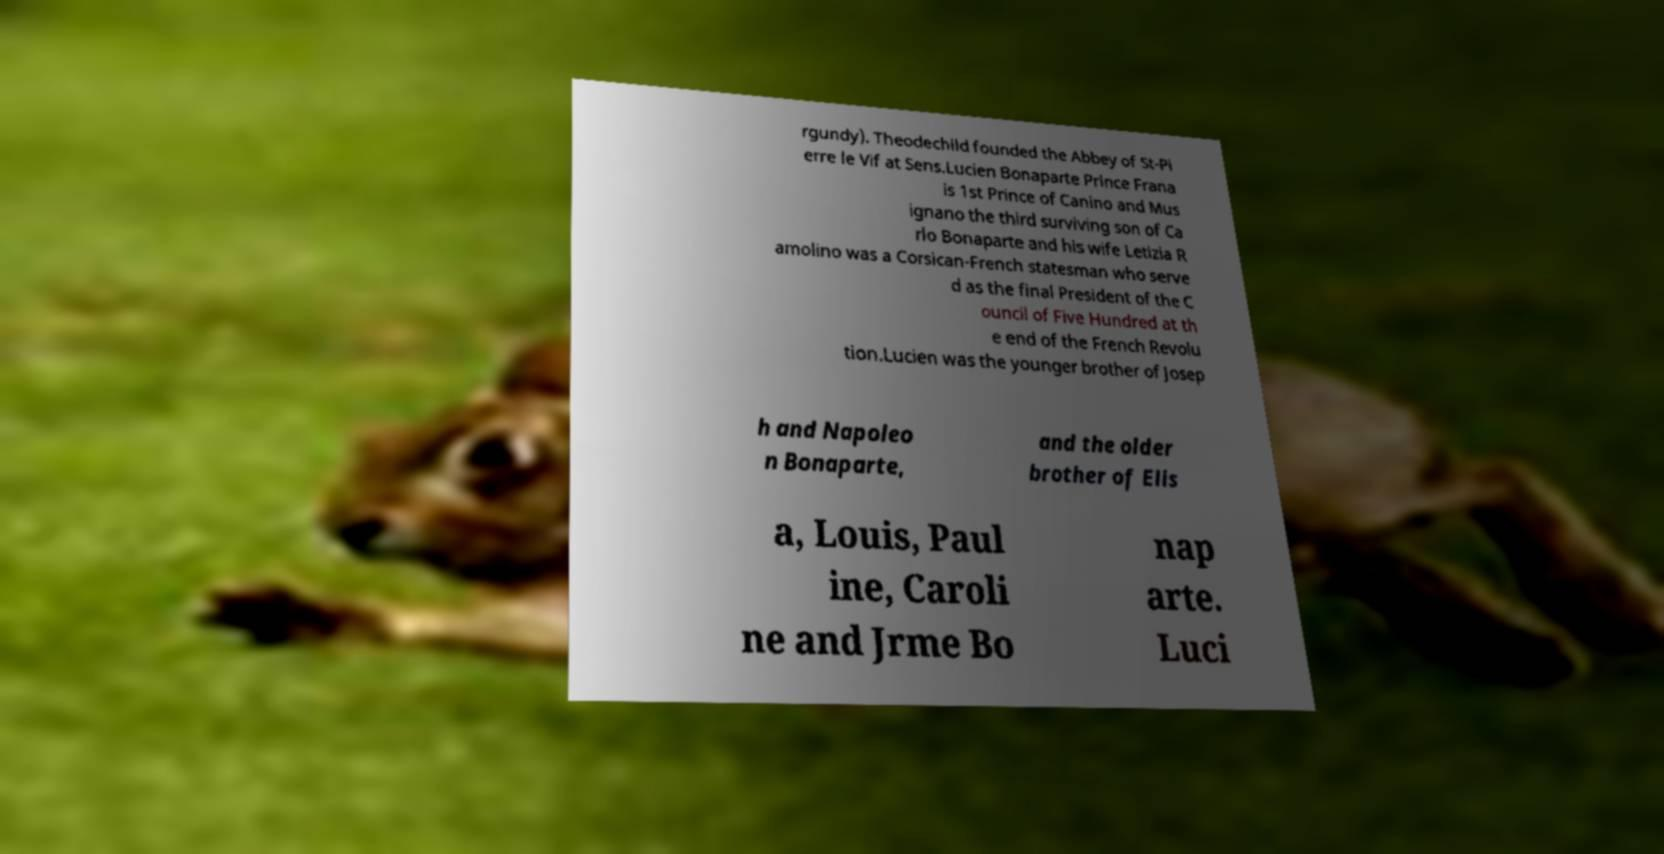For documentation purposes, I need the text within this image transcribed. Could you provide that? rgundy). Theodechild founded the Abbey of St-Pi erre le Vif at Sens.Lucien Bonaparte Prince Frana is 1st Prince of Canino and Mus ignano the third surviving son of Ca rlo Bonaparte and his wife Letizia R amolino was a Corsican-French statesman who serve d as the final President of the C ouncil of Five Hundred at th e end of the French Revolu tion.Lucien was the younger brother of Josep h and Napoleo n Bonaparte, and the older brother of Elis a, Louis, Paul ine, Caroli ne and Jrme Bo nap arte. Luci 